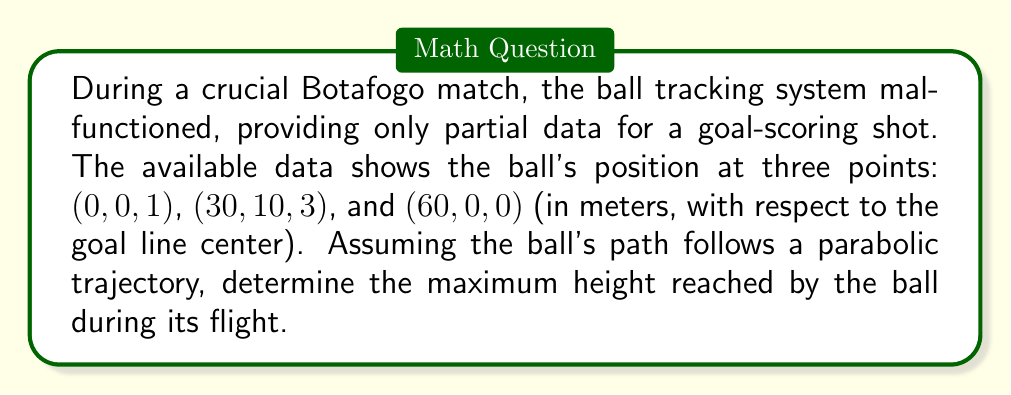Teach me how to tackle this problem. Let's approach this step-by-step:

1) The general equation for a parabolic trajectory in 3D space is:
   $$z = ax^2 + by^2 + cx + dy + e$$

2) Given the symmetry of the problem (start and end at y=0), we can simplify to:
   $$z = ax^2 + cx + e$$

3) We have three points: $(0,0,1)$, $(30,10,3)$, and $(60,0,0)$. Substituting these into our equation:
   
   $$1 = a(0)^2 + c(0) + e$$
   $$3 = a(30)^2 + c(30) + e$$
   $$0 = a(60)^2 + c(60) + e$$

4) From the first equation: $e = 1$

5) Subtracting the first equation from the other two:
   
   $$2 = 900a + 30c$$
   $$-1 = 3600a + 60c$$

6) Multiplying the first by 2 and the second by -1:
   
   $$4 = 1800a + 60c$$
   $$1 = -3600a - 60c$$

7) Adding these equations:
   
   $$5 = -1800a$$
   $$a = -\frac{1}{360}$$

8) Substituting back into $2 = 900a + 30c$:
   
   $$2 = 900(-\frac{1}{360}) + 30c$$
   $$2 = -\frac{5}{2} + 30c$$
   $$c = \frac{9}{60} = \frac{3}{20}$$

9) Now we have $z = -\frac{1}{360}x^2 + \frac{3}{20}x + 1$

10) To find the maximum height, we differentiate and set to zero:
    
    $$\frac{dz}{dx} = -\frac{1}{180}x + \frac{3}{20} = 0$$
    $$x = 27$$

11) Substituting this back into our original equation:
    
    $$z_{max} = -\frac{1}{360}(27)^2 + \frac{3}{20}(27) + 1 = 3.0625$$

Therefore, the maximum height reached by the ball is 3.0625 meters.
Answer: 3.0625 meters 